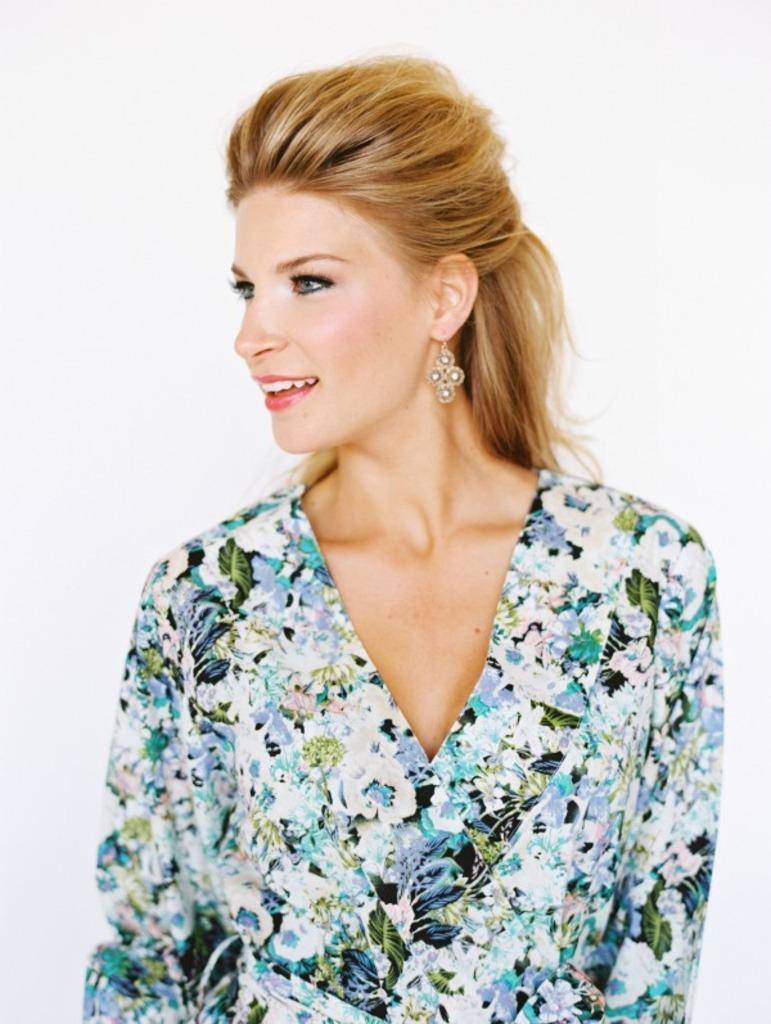Who is the main subject in the image? There is a woman in the center of the image. What is the woman doing in the image? The woman is smiling. What color is the background of the image? The background of the image is white. Where is the throne located in the image? There is no throne present in the image. What is the woman using to help her with a task in the image? There is no indication of a task or any tools in the image; the woman is simply smiling. 